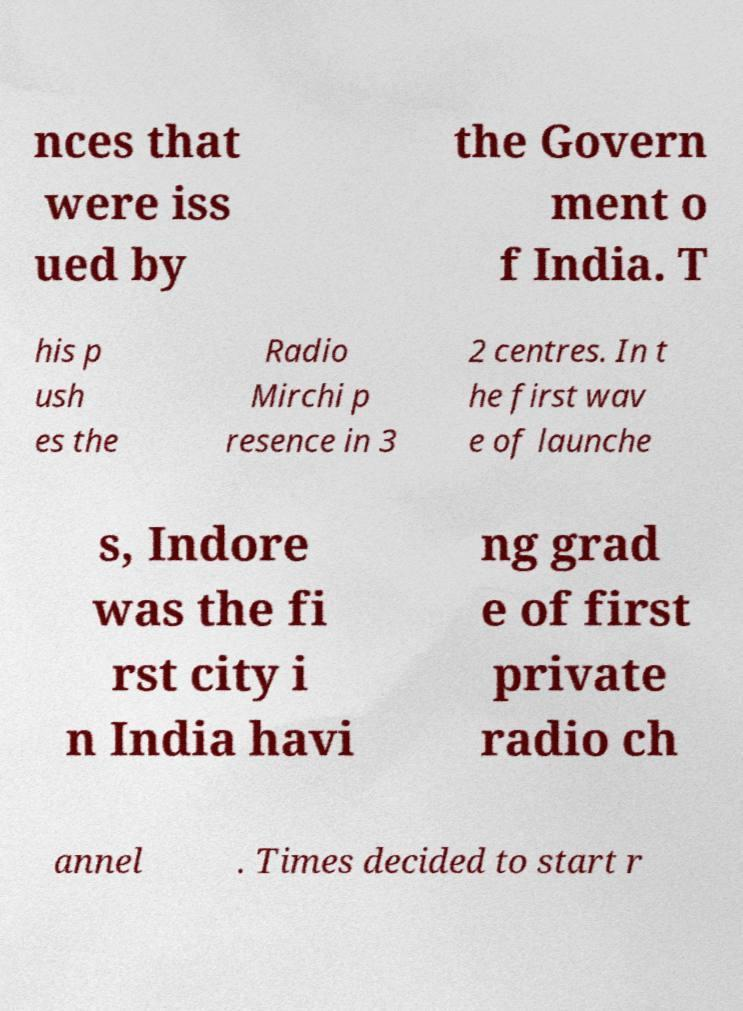Can you read and provide the text displayed in the image?This photo seems to have some interesting text. Can you extract and type it out for me? nces that were iss ued by the Govern ment o f India. T his p ush es the Radio Mirchi p resence in 3 2 centres. In t he first wav e of launche s, Indore was the fi rst city i n India havi ng grad e of first private radio ch annel . Times decided to start r 